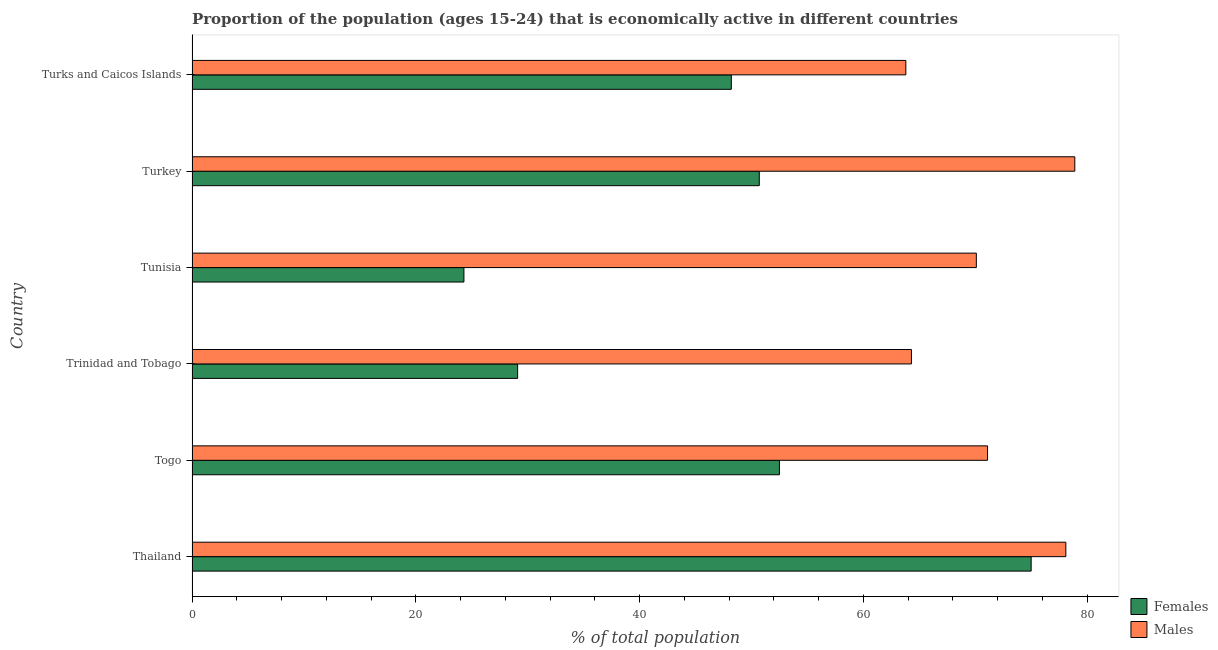Are the number of bars on each tick of the Y-axis equal?
Ensure brevity in your answer.  Yes. How many bars are there on the 3rd tick from the top?
Provide a short and direct response. 2. How many bars are there on the 3rd tick from the bottom?
Your answer should be very brief. 2. What is the label of the 5th group of bars from the top?
Make the answer very short. Togo. Across all countries, what is the maximum percentage of economically active male population?
Give a very brief answer. 78.9. Across all countries, what is the minimum percentage of economically active male population?
Make the answer very short. 63.8. In which country was the percentage of economically active male population maximum?
Your answer should be very brief. Turkey. In which country was the percentage of economically active male population minimum?
Offer a terse response. Turks and Caicos Islands. What is the total percentage of economically active male population in the graph?
Give a very brief answer. 426.3. What is the difference between the percentage of economically active female population in Turkey and the percentage of economically active male population in Tunisia?
Offer a very short reply. -19.4. What is the average percentage of economically active female population per country?
Your answer should be compact. 46.63. What is the difference between the percentage of economically active female population and percentage of economically active male population in Turkey?
Your answer should be very brief. -28.2. In how many countries, is the percentage of economically active female population greater than 16 %?
Your answer should be compact. 6. What is the ratio of the percentage of economically active female population in Thailand to that in Trinidad and Tobago?
Your answer should be compact. 2.58. Is the percentage of economically active male population in Trinidad and Tobago less than that in Tunisia?
Offer a terse response. Yes. What is the difference between the highest and the second highest percentage of economically active male population?
Your response must be concise. 0.8. What is the difference between the highest and the lowest percentage of economically active female population?
Your answer should be very brief. 50.7. What does the 1st bar from the top in Turkey represents?
Your answer should be very brief. Males. What does the 1st bar from the bottom in Turks and Caicos Islands represents?
Offer a terse response. Females. How many bars are there?
Offer a very short reply. 12. Are all the bars in the graph horizontal?
Ensure brevity in your answer.  Yes. What is the difference between two consecutive major ticks on the X-axis?
Ensure brevity in your answer.  20. Does the graph contain grids?
Provide a short and direct response. No. How are the legend labels stacked?
Provide a short and direct response. Vertical. What is the title of the graph?
Your answer should be compact. Proportion of the population (ages 15-24) that is economically active in different countries. Does "Male entrants" appear as one of the legend labels in the graph?
Provide a succinct answer. No. What is the label or title of the X-axis?
Ensure brevity in your answer.  % of total population. What is the % of total population in Males in Thailand?
Make the answer very short. 78.1. What is the % of total population in Females in Togo?
Ensure brevity in your answer.  52.5. What is the % of total population of Males in Togo?
Offer a terse response. 71.1. What is the % of total population of Females in Trinidad and Tobago?
Keep it short and to the point. 29.1. What is the % of total population of Males in Trinidad and Tobago?
Provide a short and direct response. 64.3. What is the % of total population of Females in Tunisia?
Offer a very short reply. 24.3. What is the % of total population of Males in Tunisia?
Make the answer very short. 70.1. What is the % of total population of Females in Turkey?
Your answer should be compact. 50.7. What is the % of total population of Males in Turkey?
Keep it short and to the point. 78.9. What is the % of total population of Females in Turks and Caicos Islands?
Provide a succinct answer. 48.2. What is the % of total population of Males in Turks and Caicos Islands?
Make the answer very short. 63.8. Across all countries, what is the maximum % of total population in Males?
Give a very brief answer. 78.9. Across all countries, what is the minimum % of total population of Females?
Ensure brevity in your answer.  24.3. Across all countries, what is the minimum % of total population in Males?
Provide a short and direct response. 63.8. What is the total % of total population in Females in the graph?
Your response must be concise. 279.8. What is the total % of total population of Males in the graph?
Give a very brief answer. 426.3. What is the difference between the % of total population of Females in Thailand and that in Togo?
Ensure brevity in your answer.  22.5. What is the difference between the % of total population of Males in Thailand and that in Togo?
Offer a very short reply. 7. What is the difference between the % of total population in Females in Thailand and that in Trinidad and Tobago?
Make the answer very short. 45.9. What is the difference between the % of total population in Males in Thailand and that in Trinidad and Tobago?
Give a very brief answer. 13.8. What is the difference between the % of total population in Females in Thailand and that in Tunisia?
Your answer should be very brief. 50.7. What is the difference between the % of total population of Females in Thailand and that in Turkey?
Keep it short and to the point. 24.3. What is the difference between the % of total population in Females in Thailand and that in Turks and Caicos Islands?
Make the answer very short. 26.8. What is the difference between the % of total population in Females in Togo and that in Trinidad and Tobago?
Give a very brief answer. 23.4. What is the difference between the % of total population of Males in Togo and that in Trinidad and Tobago?
Provide a short and direct response. 6.8. What is the difference between the % of total population of Females in Togo and that in Tunisia?
Provide a short and direct response. 28.2. What is the difference between the % of total population of Males in Togo and that in Tunisia?
Provide a short and direct response. 1. What is the difference between the % of total population of Males in Togo and that in Turkey?
Offer a very short reply. -7.8. What is the difference between the % of total population in Males in Trinidad and Tobago and that in Tunisia?
Your answer should be compact. -5.8. What is the difference between the % of total population in Females in Trinidad and Tobago and that in Turkey?
Your response must be concise. -21.6. What is the difference between the % of total population of Males in Trinidad and Tobago and that in Turkey?
Keep it short and to the point. -14.6. What is the difference between the % of total population of Females in Trinidad and Tobago and that in Turks and Caicos Islands?
Keep it short and to the point. -19.1. What is the difference between the % of total population of Females in Tunisia and that in Turkey?
Offer a very short reply. -26.4. What is the difference between the % of total population in Females in Tunisia and that in Turks and Caicos Islands?
Provide a short and direct response. -23.9. What is the difference between the % of total population of Males in Tunisia and that in Turks and Caicos Islands?
Offer a terse response. 6.3. What is the difference between the % of total population of Females in Turkey and that in Turks and Caicos Islands?
Your answer should be compact. 2.5. What is the difference between the % of total population of Males in Turkey and that in Turks and Caicos Islands?
Give a very brief answer. 15.1. What is the difference between the % of total population of Females in Thailand and the % of total population of Males in Togo?
Offer a terse response. 3.9. What is the difference between the % of total population of Females in Thailand and the % of total population of Males in Tunisia?
Offer a terse response. 4.9. What is the difference between the % of total population in Females in Togo and the % of total population in Males in Trinidad and Tobago?
Your response must be concise. -11.8. What is the difference between the % of total population of Females in Togo and the % of total population of Males in Tunisia?
Offer a very short reply. -17.6. What is the difference between the % of total population in Females in Togo and the % of total population in Males in Turkey?
Ensure brevity in your answer.  -26.4. What is the difference between the % of total population in Females in Togo and the % of total population in Males in Turks and Caicos Islands?
Ensure brevity in your answer.  -11.3. What is the difference between the % of total population of Females in Trinidad and Tobago and the % of total population of Males in Tunisia?
Your answer should be very brief. -41. What is the difference between the % of total population in Females in Trinidad and Tobago and the % of total population in Males in Turkey?
Ensure brevity in your answer.  -49.8. What is the difference between the % of total population in Females in Trinidad and Tobago and the % of total population in Males in Turks and Caicos Islands?
Your answer should be compact. -34.7. What is the difference between the % of total population in Females in Tunisia and the % of total population in Males in Turkey?
Ensure brevity in your answer.  -54.6. What is the difference between the % of total population in Females in Tunisia and the % of total population in Males in Turks and Caicos Islands?
Keep it short and to the point. -39.5. What is the average % of total population in Females per country?
Offer a terse response. 46.63. What is the average % of total population in Males per country?
Ensure brevity in your answer.  71.05. What is the difference between the % of total population in Females and % of total population in Males in Thailand?
Your answer should be compact. -3.1. What is the difference between the % of total population of Females and % of total population of Males in Togo?
Make the answer very short. -18.6. What is the difference between the % of total population in Females and % of total population in Males in Trinidad and Tobago?
Provide a succinct answer. -35.2. What is the difference between the % of total population in Females and % of total population in Males in Tunisia?
Provide a succinct answer. -45.8. What is the difference between the % of total population of Females and % of total population of Males in Turkey?
Provide a short and direct response. -28.2. What is the difference between the % of total population of Females and % of total population of Males in Turks and Caicos Islands?
Your answer should be compact. -15.6. What is the ratio of the % of total population in Females in Thailand to that in Togo?
Provide a succinct answer. 1.43. What is the ratio of the % of total population in Males in Thailand to that in Togo?
Give a very brief answer. 1.1. What is the ratio of the % of total population of Females in Thailand to that in Trinidad and Tobago?
Make the answer very short. 2.58. What is the ratio of the % of total population in Males in Thailand to that in Trinidad and Tobago?
Your answer should be compact. 1.21. What is the ratio of the % of total population in Females in Thailand to that in Tunisia?
Your response must be concise. 3.09. What is the ratio of the % of total population in Males in Thailand to that in Tunisia?
Provide a succinct answer. 1.11. What is the ratio of the % of total population in Females in Thailand to that in Turkey?
Your answer should be very brief. 1.48. What is the ratio of the % of total population of Females in Thailand to that in Turks and Caicos Islands?
Your response must be concise. 1.56. What is the ratio of the % of total population in Males in Thailand to that in Turks and Caicos Islands?
Your response must be concise. 1.22. What is the ratio of the % of total population in Females in Togo to that in Trinidad and Tobago?
Give a very brief answer. 1.8. What is the ratio of the % of total population of Males in Togo to that in Trinidad and Tobago?
Give a very brief answer. 1.11. What is the ratio of the % of total population in Females in Togo to that in Tunisia?
Offer a very short reply. 2.16. What is the ratio of the % of total population in Males in Togo to that in Tunisia?
Keep it short and to the point. 1.01. What is the ratio of the % of total population in Females in Togo to that in Turkey?
Offer a very short reply. 1.04. What is the ratio of the % of total population of Males in Togo to that in Turkey?
Your answer should be very brief. 0.9. What is the ratio of the % of total population of Females in Togo to that in Turks and Caicos Islands?
Your answer should be very brief. 1.09. What is the ratio of the % of total population in Males in Togo to that in Turks and Caicos Islands?
Your answer should be very brief. 1.11. What is the ratio of the % of total population in Females in Trinidad and Tobago to that in Tunisia?
Keep it short and to the point. 1.2. What is the ratio of the % of total population of Males in Trinidad and Tobago to that in Tunisia?
Offer a terse response. 0.92. What is the ratio of the % of total population of Females in Trinidad and Tobago to that in Turkey?
Offer a terse response. 0.57. What is the ratio of the % of total population of Males in Trinidad and Tobago to that in Turkey?
Provide a succinct answer. 0.81. What is the ratio of the % of total population in Females in Trinidad and Tobago to that in Turks and Caicos Islands?
Keep it short and to the point. 0.6. What is the ratio of the % of total population of Females in Tunisia to that in Turkey?
Offer a terse response. 0.48. What is the ratio of the % of total population of Males in Tunisia to that in Turkey?
Ensure brevity in your answer.  0.89. What is the ratio of the % of total population in Females in Tunisia to that in Turks and Caicos Islands?
Your answer should be very brief. 0.5. What is the ratio of the % of total population of Males in Tunisia to that in Turks and Caicos Islands?
Your response must be concise. 1.1. What is the ratio of the % of total population of Females in Turkey to that in Turks and Caicos Islands?
Make the answer very short. 1.05. What is the ratio of the % of total population of Males in Turkey to that in Turks and Caicos Islands?
Provide a succinct answer. 1.24. What is the difference between the highest and the lowest % of total population in Females?
Offer a very short reply. 50.7. 